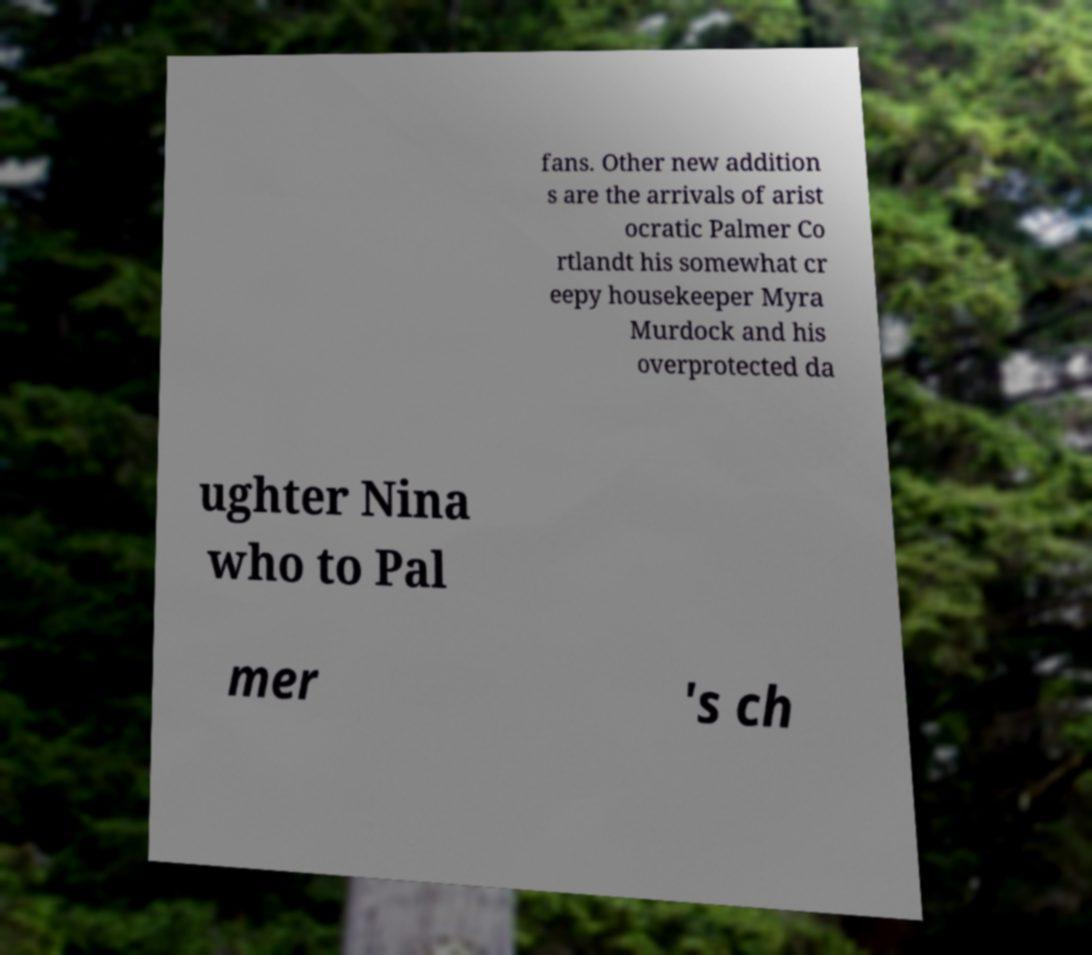Could you extract and type out the text from this image? fans. Other new addition s are the arrivals of arist ocratic Palmer Co rtlandt his somewhat cr eepy housekeeper Myra Murdock and his overprotected da ughter Nina who to Pal mer 's ch 